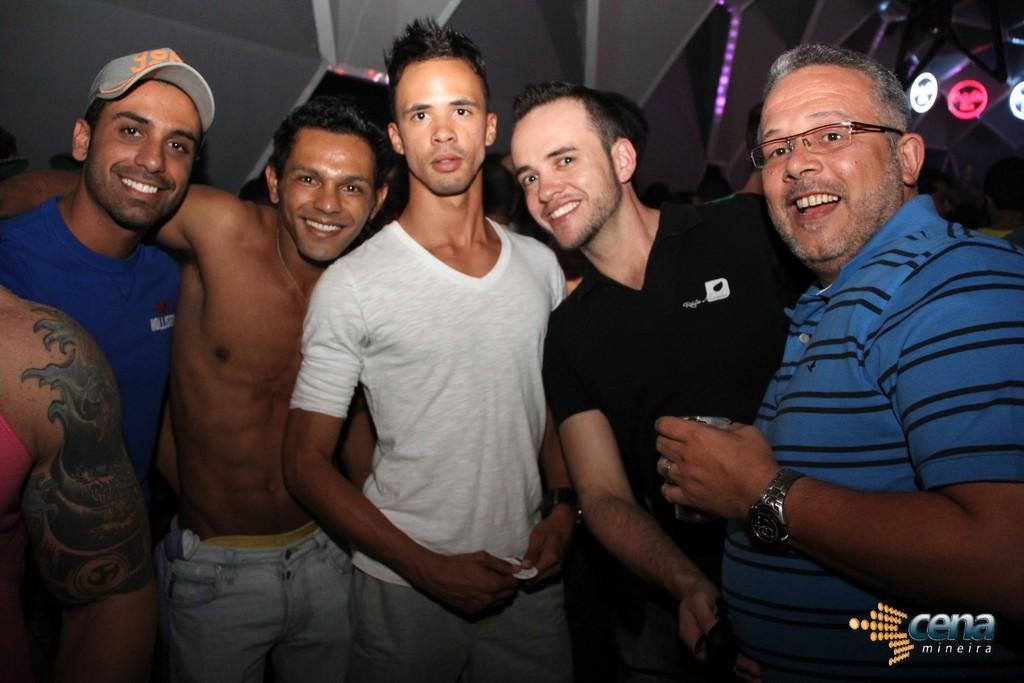What is happening in the foreground of the image? There are men standing in the foreground of the image. What are the men doing in the image? The men are posing for the camera. What can be seen in the background of the image? There is a ceiling and lights visible in the background of the image. What type of cap is the man wearing in the image? There is no mention of a cap in the provided facts, and no cap is visible in the image. 